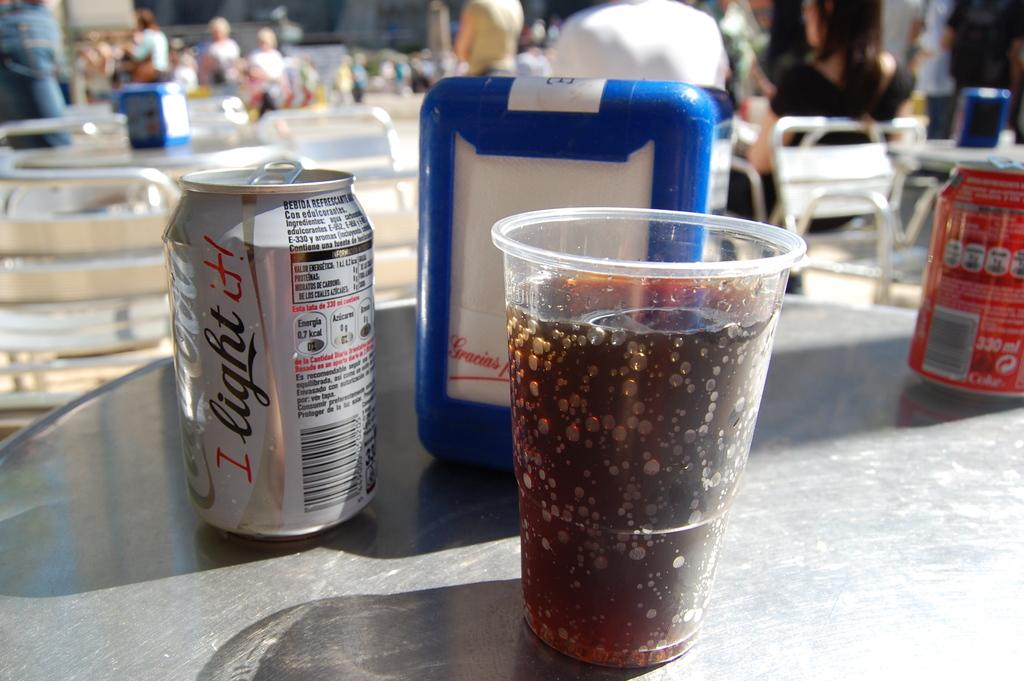<image>
Create a compact narrative representing the image presented. A plastic cup full of soda sits on a table next to a can of Coca-Cola Light. 